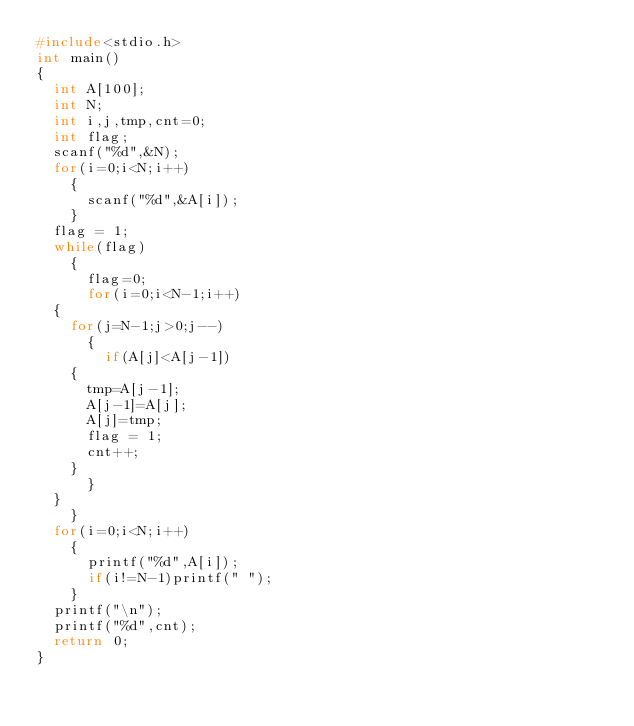Convert code to text. <code><loc_0><loc_0><loc_500><loc_500><_C_>#include<stdio.h>
int main()
{
  int A[100];
  int N;
  int i,j,tmp,cnt=0;
  int flag;
  scanf("%d",&N);
  for(i=0;i<N;i++)
    {
      scanf("%d",&A[i]);
    }
  flag = 1;
  while(flag)
    {
      flag=0;
      for(i=0;i<N-1;i++)
	{
	  for(j=N-1;j>0;j--)
	    {
	      if(A[j]<A[j-1])
		{
		  tmp=A[j-1];
		  A[j-1]=A[j];
		  A[j]=tmp;
		  flag = 1;
		  cnt++;
		}
	    }
	}
    }
  for(i=0;i<N;i++)
    {
      printf("%d",A[i]);
      if(i!=N-1)printf(" ");
    }
  printf("\n");
  printf("%d",cnt);
  return 0;
}</code> 